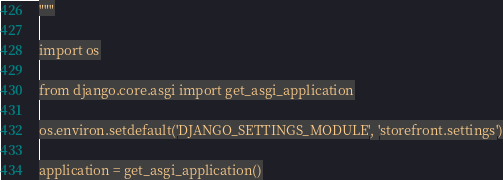Convert code to text. <code><loc_0><loc_0><loc_500><loc_500><_Python_>"""

import os

from django.core.asgi import get_asgi_application

os.environ.setdefault('DJANGO_SETTINGS_MODULE', 'storefront.settings')

application = get_asgi_application()
</code> 